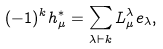<formula> <loc_0><loc_0><loc_500><loc_500>( - 1 ) ^ { k } h ^ { * } _ { \mu } = \sum _ { \lambda \vdash k } L ^ { \lambda } _ { \mu } e _ { \lambda } ,</formula> 